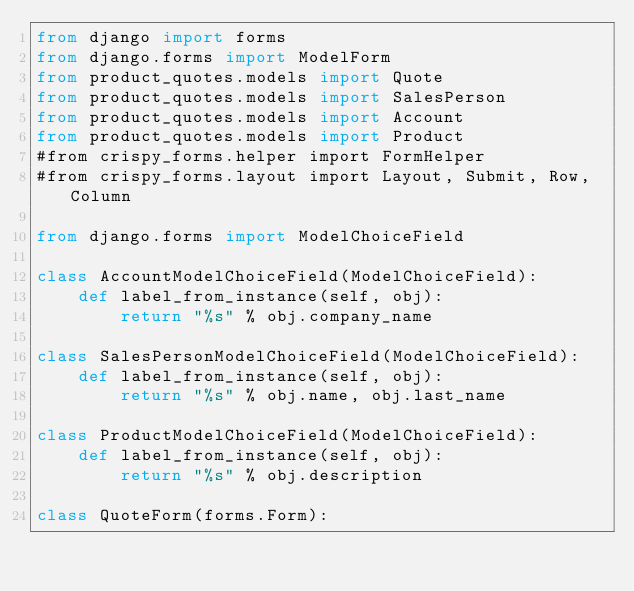<code> <loc_0><loc_0><loc_500><loc_500><_Python_>from django import forms
from django.forms import ModelForm
from product_quotes.models import Quote
from product_quotes.models import SalesPerson
from product_quotes.models import Account
from product_quotes.models import Product
#from crispy_forms.helper import FormHelper
#from crispy_forms.layout import Layout, Submit, Row, Column

from django.forms import ModelChoiceField

class AccountModelChoiceField(ModelChoiceField):
    def label_from_instance(self, obj):
        return "%s" % obj.company_name

class SalesPersonModelChoiceField(ModelChoiceField):
    def label_from_instance(self, obj):
        return "%s" % obj.name, obj.last_name

class ProductModelChoiceField(ModelChoiceField):
    def label_from_instance(self, obj):
        return "%s" % obj.description

class QuoteForm(forms.Form):</code> 